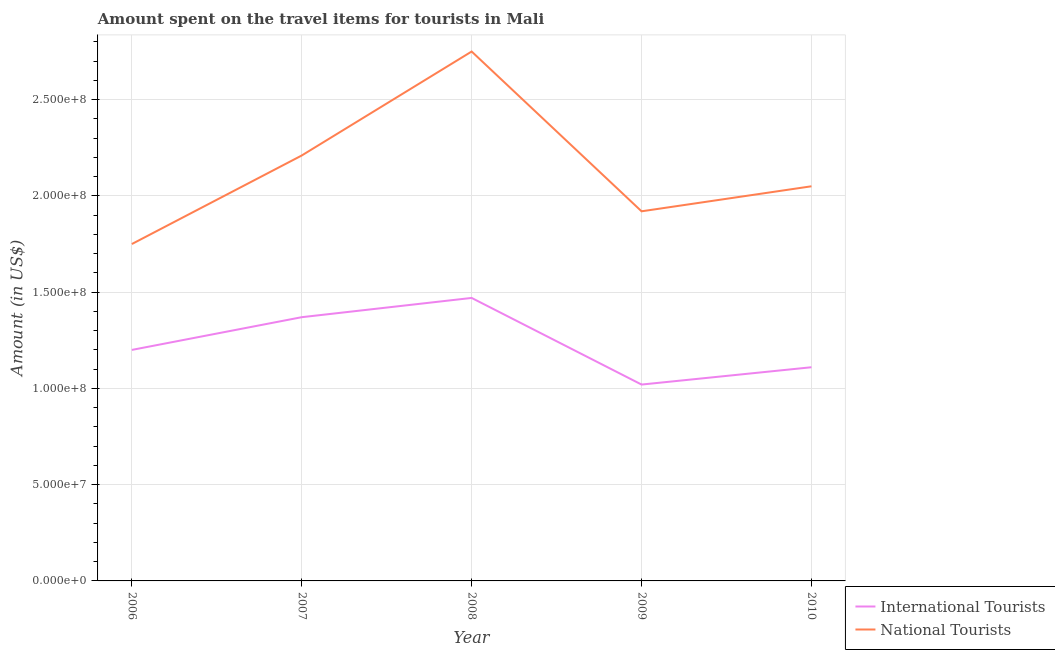Does the line corresponding to amount spent on travel items of international tourists intersect with the line corresponding to amount spent on travel items of national tourists?
Make the answer very short. No. What is the amount spent on travel items of international tourists in 2006?
Your response must be concise. 1.20e+08. Across all years, what is the maximum amount spent on travel items of international tourists?
Provide a short and direct response. 1.47e+08. Across all years, what is the minimum amount spent on travel items of international tourists?
Ensure brevity in your answer.  1.02e+08. In which year was the amount spent on travel items of national tourists maximum?
Provide a succinct answer. 2008. In which year was the amount spent on travel items of national tourists minimum?
Provide a short and direct response. 2006. What is the total amount spent on travel items of international tourists in the graph?
Provide a short and direct response. 6.17e+08. What is the difference between the amount spent on travel items of national tourists in 2007 and that in 2010?
Offer a very short reply. 1.60e+07. What is the difference between the amount spent on travel items of national tourists in 2010 and the amount spent on travel items of international tourists in 2006?
Make the answer very short. 8.50e+07. What is the average amount spent on travel items of international tourists per year?
Your answer should be compact. 1.23e+08. In the year 2009, what is the difference between the amount spent on travel items of national tourists and amount spent on travel items of international tourists?
Offer a very short reply. 9.00e+07. What is the ratio of the amount spent on travel items of international tourists in 2009 to that in 2010?
Offer a terse response. 0.92. Is the amount spent on travel items of national tourists in 2008 less than that in 2010?
Provide a short and direct response. No. What is the difference between the highest and the second highest amount spent on travel items of national tourists?
Offer a very short reply. 5.40e+07. What is the difference between the highest and the lowest amount spent on travel items of national tourists?
Your answer should be very brief. 1.00e+08. In how many years, is the amount spent on travel items of national tourists greater than the average amount spent on travel items of national tourists taken over all years?
Your response must be concise. 2. Is the sum of the amount spent on travel items of international tourists in 2008 and 2009 greater than the maximum amount spent on travel items of national tourists across all years?
Ensure brevity in your answer.  No. What is the difference between two consecutive major ticks on the Y-axis?
Offer a terse response. 5.00e+07. Where does the legend appear in the graph?
Your response must be concise. Bottom right. How are the legend labels stacked?
Keep it short and to the point. Vertical. What is the title of the graph?
Provide a short and direct response. Amount spent on the travel items for tourists in Mali. What is the label or title of the X-axis?
Your answer should be very brief. Year. What is the label or title of the Y-axis?
Provide a succinct answer. Amount (in US$). What is the Amount (in US$) in International Tourists in 2006?
Offer a very short reply. 1.20e+08. What is the Amount (in US$) in National Tourists in 2006?
Offer a very short reply. 1.75e+08. What is the Amount (in US$) of International Tourists in 2007?
Your answer should be very brief. 1.37e+08. What is the Amount (in US$) of National Tourists in 2007?
Your answer should be compact. 2.21e+08. What is the Amount (in US$) of International Tourists in 2008?
Provide a succinct answer. 1.47e+08. What is the Amount (in US$) of National Tourists in 2008?
Give a very brief answer. 2.75e+08. What is the Amount (in US$) in International Tourists in 2009?
Your answer should be very brief. 1.02e+08. What is the Amount (in US$) of National Tourists in 2009?
Your answer should be compact. 1.92e+08. What is the Amount (in US$) of International Tourists in 2010?
Ensure brevity in your answer.  1.11e+08. What is the Amount (in US$) in National Tourists in 2010?
Your answer should be very brief. 2.05e+08. Across all years, what is the maximum Amount (in US$) of International Tourists?
Keep it short and to the point. 1.47e+08. Across all years, what is the maximum Amount (in US$) in National Tourists?
Provide a short and direct response. 2.75e+08. Across all years, what is the minimum Amount (in US$) of International Tourists?
Your answer should be very brief. 1.02e+08. Across all years, what is the minimum Amount (in US$) in National Tourists?
Make the answer very short. 1.75e+08. What is the total Amount (in US$) of International Tourists in the graph?
Your response must be concise. 6.17e+08. What is the total Amount (in US$) of National Tourists in the graph?
Your response must be concise. 1.07e+09. What is the difference between the Amount (in US$) of International Tourists in 2006 and that in 2007?
Give a very brief answer. -1.70e+07. What is the difference between the Amount (in US$) in National Tourists in 2006 and that in 2007?
Give a very brief answer. -4.60e+07. What is the difference between the Amount (in US$) of International Tourists in 2006 and that in 2008?
Give a very brief answer. -2.70e+07. What is the difference between the Amount (in US$) of National Tourists in 2006 and that in 2008?
Give a very brief answer. -1.00e+08. What is the difference between the Amount (in US$) in International Tourists in 2006 and that in 2009?
Make the answer very short. 1.80e+07. What is the difference between the Amount (in US$) in National Tourists in 2006 and that in 2009?
Offer a terse response. -1.70e+07. What is the difference between the Amount (in US$) of International Tourists in 2006 and that in 2010?
Give a very brief answer. 9.00e+06. What is the difference between the Amount (in US$) of National Tourists in 2006 and that in 2010?
Keep it short and to the point. -3.00e+07. What is the difference between the Amount (in US$) of International Tourists in 2007 and that in 2008?
Provide a short and direct response. -1.00e+07. What is the difference between the Amount (in US$) of National Tourists in 2007 and that in 2008?
Your answer should be compact. -5.40e+07. What is the difference between the Amount (in US$) in International Tourists in 2007 and that in 2009?
Keep it short and to the point. 3.50e+07. What is the difference between the Amount (in US$) in National Tourists in 2007 and that in 2009?
Give a very brief answer. 2.90e+07. What is the difference between the Amount (in US$) of International Tourists in 2007 and that in 2010?
Your answer should be very brief. 2.60e+07. What is the difference between the Amount (in US$) in National Tourists in 2007 and that in 2010?
Offer a terse response. 1.60e+07. What is the difference between the Amount (in US$) in International Tourists in 2008 and that in 2009?
Provide a succinct answer. 4.50e+07. What is the difference between the Amount (in US$) in National Tourists in 2008 and that in 2009?
Keep it short and to the point. 8.30e+07. What is the difference between the Amount (in US$) of International Tourists in 2008 and that in 2010?
Give a very brief answer. 3.60e+07. What is the difference between the Amount (in US$) in National Tourists in 2008 and that in 2010?
Your answer should be compact. 7.00e+07. What is the difference between the Amount (in US$) of International Tourists in 2009 and that in 2010?
Ensure brevity in your answer.  -9.00e+06. What is the difference between the Amount (in US$) in National Tourists in 2009 and that in 2010?
Ensure brevity in your answer.  -1.30e+07. What is the difference between the Amount (in US$) of International Tourists in 2006 and the Amount (in US$) of National Tourists in 2007?
Your answer should be very brief. -1.01e+08. What is the difference between the Amount (in US$) in International Tourists in 2006 and the Amount (in US$) in National Tourists in 2008?
Keep it short and to the point. -1.55e+08. What is the difference between the Amount (in US$) of International Tourists in 2006 and the Amount (in US$) of National Tourists in 2009?
Offer a very short reply. -7.20e+07. What is the difference between the Amount (in US$) of International Tourists in 2006 and the Amount (in US$) of National Tourists in 2010?
Offer a very short reply. -8.50e+07. What is the difference between the Amount (in US$) in International Tourists in 2007 and the Amount (in US$) in National Tourists in 2008?
Your answer should be very brief. -1.38e+08. What is the difference between the Amount (in US$) in International Tourists in 2007 and the Amount (in US$) in National Tourists in 2009?
Provide a succinct answer. -5.50e+07. What is the difference between the Amount (in US$) of International Tourists in 2007 and the Amount (in US$) of National Tourists in 2010?
Provide a succinct answer. -6.80e+07. What is the difference between the Amount (in US$) in International Tourists in 2008 and the Amount (in US$) in National Tourists in 2009?
Offer a terse response. -4.50e+07. What is the difference between the Amount (in US$) of International Tourists in 2008 and the Amount (in US$) of National Tourists in 2010?
Provide a succinct answer. -5.80e+07. What is the difference between the Amount (in US$) in International Tourists in 2009 and the Amount (in US$) in National Tourists in 2010?
Keep it short and to the point. -1.03e+08. What is the average Amount (in US$) in International Tourists per year?
Provide a short and direct response. 1.23e+08. What is the average Amount (in US$) of National Tourists per year?
Provide a short and direct response. 2.14e+08. In the year 2006, what is the difference between the Amount (in US$) of International Tourists and Amount (in US$) of National Tourists?
Ensure brevity in your answer.  -5.50e+07. In the year 2007, what is the difference between the Amount (in US$) in International Tourists and Amount (in US$) in National Tourists?
Give a very brief answer. -8.40e+07. In the year 2008, what is the difference between the Amount (in US$) in International Tourists and Amount (in US$) in National Tourists?
Your answer should be compact. -1.28e+08. In the year 2009, what is the difference between the Amount (in US$) in International Tourists and Amount (in US$) in National Tourists?
Offer a very short reply. -9.00e+07. In the year 2010, what is the difference between the Amount (in US$) of International Tourists and Amount (in US$) of National Tourists?
Provide a short and direct response. -9.40e+07. What is the ratio of the Amount (in US$) of International Tourists in 2006 to that in 2007?
Keep it short and to the point. 0.88. What is the ratio of the Amount (in US$) in National Tourists in 2006 to that in 2007?
Your answer should be very brief. 0.79. What is the ratio of the Amount (in US$) in International Tourists in 2006 to that in 2008?
Your response must be concise. 0.82. What is the ratio of the Amount (in US$) of National Tourists in 2006 to that in 2008?
Offer a very short reply. 0.64. What is the ratio of the Amount (in US$) in International Tourists in 2006 to that in 2009?
Make the answer very short. 1.18. What is the ratio of the Amount (in US$) in National Tourists in 2006 to that in 2009?
Offer a very short reply. 0.91. What is the ratio of the Amount (in US$) of International Tourists in 2006 to that in 2010?
Provide a short and direct response. 1.08. What is the ratio of the Amount (in US$) of National Tourists in 2006 to that in 2010?
Provide a short and direct response. 0.85. What is the ratio of the Amount (in US$) in International Tourists in 2007 to that in 2008?
Offer a terse response. 0.93. What is the ratio of the Amount (in US$) in National Tourists in 2007 to that in 2008?
Your answer should be very brief. 0.8. What is the ratio of the Amount (in US$) of International Tourists in 2007 to that in 2009?
Your answer should be compact. 1.34. What is the ratio of the Amount (in US$) of National Tourists in 2007 to that in 2009?
Keep it short and to the point. 1.15. What is the ratio of the Amount (in US$) in International Tourists in 2007 to that in 2010?
Offer a terse response. 1.23. What is the ratio of the Amount (in US$) of National Tourists in 2007 to that in 2010?
Offer a very short reply. 1.08. What is the ratio of the Amount (in US$) in International Tourists in 2008 to that in 2009?
Your answer should be compact. 1.44. What is the ratio of the Amount (in US$) in National Tourists in 2008 to that in 2009?
Your answer should be very brief. 1.43. What is the ratio of the Amount (in US$) in International Tourists in 2008 to that in 2010?
Give a very brief answer. 1.32. What is the ratio of the Amount (in US$) of National Tourists in 2008 to that in 2010?
Make the answer very short. 1.34. What is the ratio of the Amount (in US$) of International Tourists in 2009 to that in 2010?
Your answer should be very brief. 0.92. What is the ratio of the Amount (in US$) in National Tourists in 2009 to that in 2010?
Ensure brevity in your answer.  0.94. What is the difference between the highest and the second highest Amount (in US$) in National Tourists?
Your response must be concise. 5.40e+07. What is the difference between the highest and the lowest Amount (in US$) in International Tourists?
Your answer should be compact. 4.50e+07. 